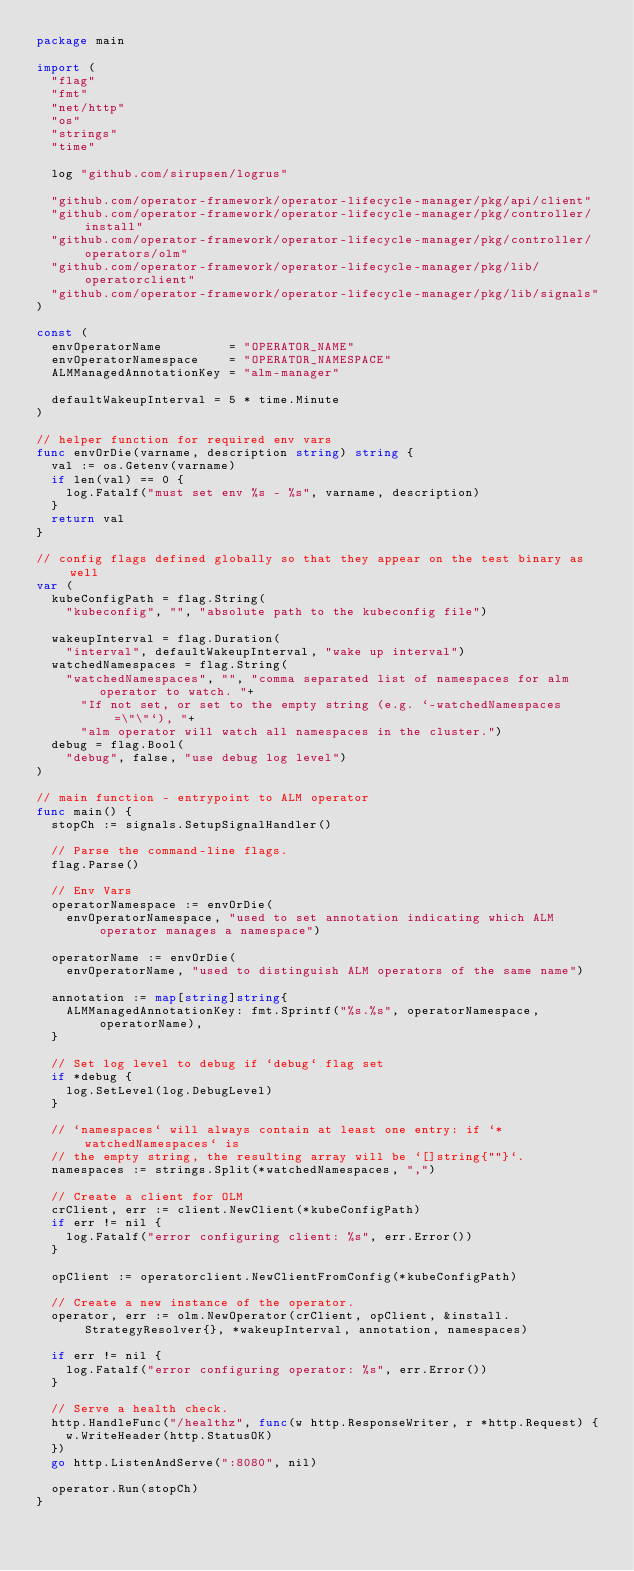Convert code to text. <code><loc_0><loc_0><loc_500><loc_500><_Go_>package main

import (
	"flag"
	"fmt"
	"net/http"
	"os"
	"strings"
	"time"

	log "github.com/sirupsen/logrus"

	"github.com/operator-framework/operator-lifecycle-manager/pkg/api/client"
	"github.com/operator-framework/operator-lifecycle-manager/pkg/controller/install"
	"github.com/operator-framework/operator-lifecycle-manager/pkg/controller/operators/olm"
	"github.com/operator-framework/operator-lifecycle-manager/pkg/lib/operatorclient"
	"github.com/operator-framework/operator-lifecycle-manager/pkg/lib/signals"
)

const (
	envOperatorName         = "OPERATOR_NAME"
	envOperatorNamespace    = "OPERATOR_NAMESPACE"
	ALMManagedAnnotationKey = "alm-manager"

	defaultWakeupInterval = 5 * time.Minute
)

// helper function for required env vars
func envOrDie(varname, description string) string {
	val := os.Getenv(varname)
	if len(val) == 0 {
		log.Fatalf("must set env %s - %s", varname, description)
	}
	return val
}

// config flags defined globally so that they appear on the test binary as well
var (
	kubeConfigPath = flag.String(
		"kubeconfig", "", "absolute path to the kubeconfig file")

	wakeupInterval = flag.Duration(
		"interval", defaultWakeupInterval, "wake up interval")
	watchedNamespaces = flag.String(
		"watchedNamespaces", "", "comma separated list of namespaces for alm operator to watch. "+
			"If not set, or set to the empty string (e.g. `-watchedNamespaces=\"\"`), "+
			"alm operator will watch all namespaces in the cluster.")
	debug = flag.Bool(
		"debug", false, "use debug log level")
)

// main function - entrypoint to ALM operator
func main() {
	stopCh := signals.SetupSignalHandler()

	// Parse the command-line flags.
	flag.Parse()

	// Env Vars
	operatorNamespace := envOrDie(
		envOperatorNamespace, "used to set annotation indicating which ALM operator manages a namespace")

	operatorName := envOrDie(
		envOperatorName, "used to distinguish ALM operators of the same name")

	annotation := map[string]string{
		ALMManagedAnnotationKey: fmt.Sprintf("%s.%s", operatorNamespace, operatorName),
	}

	// Set log level to debug if `debug` flag set
	if *debug {
		log.SetLevel(log.DebugLevel)
	}

	// `namespaces` will always contain at least one entry: if `*watchedNamespaces` is
	// the empty string, the resulting array will be `[]string{""}`.
	namespaces := strings.Split(*watchedNamespaces, ",")

	// Create a client for OLM
	crClient, err := client.NewClient(*kubeConfigPath)
	if err != nil {
		log.Fatalf("error configuring client: %s", err.Error())
	}

	opClient := operatorclient.NewClientFromConfig(*kubeConfigPath)

	// Create a new instance of the operator.
	operator, err := olm.NewOperator(crClient, opClient, &install.StrategyResolver{}, *wakeupInterval, annotation, namespaces)

	if err != nil {
		log.Fatalf("error configuring operator: %s", err.Error())
	}

	// Serve a health check.
	http.HandleFunc("/healthz", func(w http.ResponseWriter, r *http.Request) {
		w.WriteHeader(http.StatusOK)
	})
	go http.ListenAndServe(":8080", nil)

	operator.Run(stopCh)
}
</code> 